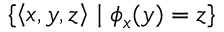<formula> <loc_0><loc_0><loc_500><loc_500>\{ \left \langle x , y , z \right \rangle | \phi _ { x } ( y ) = z \}</formula> 